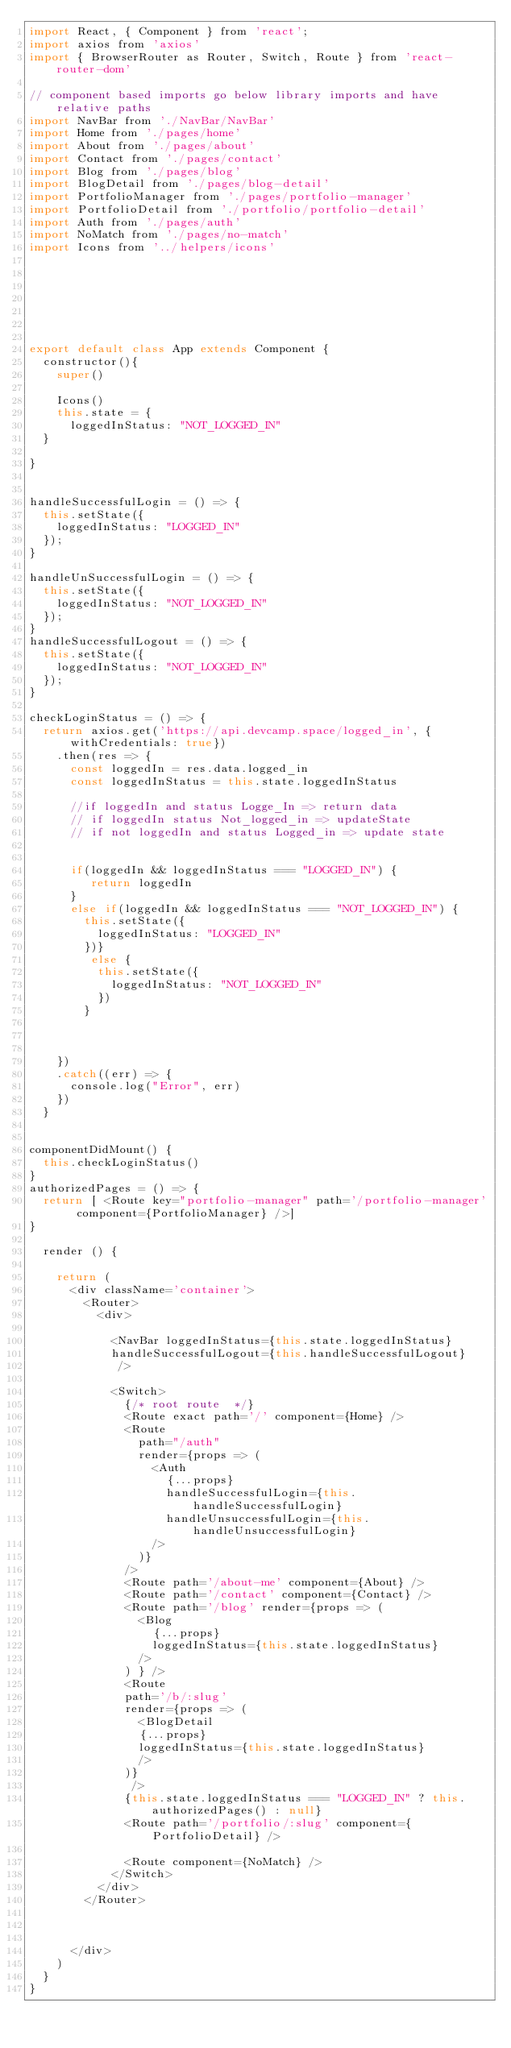Convert code to text. <code><loc_0><loc_0><loc_500><loc_500><_JavaScript_>import React, { Component } from 'react';
import axios from 'axios'
import { BrowserRouter as Router, Switch, Route } from 'react-router-dom'

// component based imports go below library imports and have relative paths 
import NavBar from './NavBar/NavBar'
import Home from './pages/home'
import About from './pages/about'
import Contact from './pages/contact'
import Blog from './pages/blog'
import BlogDetail from './pages/blog-detail'
import PortfolioManager from './pages/portfolio-manager'
import PortfolioDetail from './portfolio/portfolio-detail'
import Auth from './pages/auth'
import NoMatch from './pages/no-match'
import Icons from '../helpers/icons'







export default class App extends Component {
  constructor(){
    super()

    Icons()
    this.state = {
      loggedInStatus: "NOT_LOGGED_IN"
  }

}


handleSuccessfulLogin = () => {
  this.setState({
    loggedInStatus: "LOGGED_IN"
  });
}

handleUnSuccessfulLogin = () => {
  this.setState({
    loggedInStatus: "NOT_LOGGED_IN"
  });
}
handleSuccessfulLogout = () => {
  this.setState({
    loggedInStatus: "NOT_LOGGED_IN"
  });
}

checkLoginStatus = () => {
  return axios.get('https://api.devcamp.space/logged_in', { withCredentials: true})
    .then(res => {
      const loggedIn = res.data.logged_in
      const loggedInStatus = this.state.loggedInStatus

      //if loggedIn and status Logge_In => return data
      // if loggedIn status Not_logged_in => updateState
      // if not loggedIn and status Logged_in => update state


      if(loggedIn && loggedInStatus === "LOGGED_IN") {
         return loggedIn
      } 
      else if(loggedIn && loggedInStatus === "NOT_LOGGED_IN") {
        this.setState({
          loggedInStatus: "LOGGED_IN"
        })}
         else {
          this.setState({
            loggedInStatus: "NOT_LOGGED_IN"  
          })
        }
      
      
      
    })
    .catch((err) => {
      console.log("Error", err)
    })
  }


componentDidMount() {
  this.checkLoginStatus()
}
authorizedPages = () => {
  return [ <Route key="portfolio-manager" path='/portfolio-manager' component={PortfolioManager} />]
}

  render () {
    
    return (
      <div className='container'>
        <Router>
          <div>
          
            <NavBar loggedInStatus={this.state.loggedInStatus}
            handleSuccessfulLogout={this.handleSuccessfulLogout}
             />
           
            <Switch>
              {/* root route  */}
              <Route exact path='/' component={Home} />
              <Route
                path="/auth"
                render={props => (
                  <Auth
                    {...props}
                    handleSuccessfulLogin={this.handleSuccessfulLogin}
                    handleUnsuccessfulLogin={this.handleUnsuccessfulLogin}
                  />
                )}
              />
              <Route path='/about-me' component={About} />
              <Route path='/contact' component={Contact} />              
              <Route path='/blog' render={props => (
                <Blog
                  {...props}
                  loggedInStatus={this.state.loggedInStatus}
                />
              ) } />
              <Route 
              path='/b/:slug' 
              render={props => (
                <BlogDetail 
                {...props}
                loggedInStatus={this.state.loggedInStatus}
                />
              )}              
               /> 
              {this.state.loggedInStatus === "LOGGED_IN" ? this.authorizedPages() : null}
              <Route path='/portfolio/:slug' component={PortfolioDetail} />
              
              <Route component={NoMatch} />
            </Switch>
          </div>
        </Router>

        
        
      </div>
    )
  }
}


</code> 